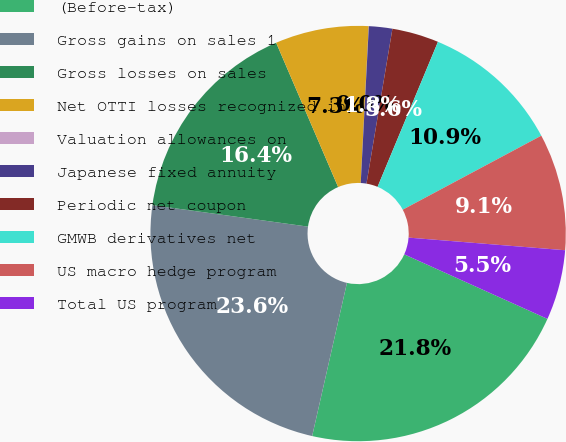Convert chart to OTSL. <chart><loc_0><loc_0><loc_500><loc_500><pie_chart><fcel>(Before-tax)<fcel>Gross gains on sales 1<fcel>Gross losses on sales<fcel>Net OTTI losses recognized in<fcel>Valuation allowances on<fcel>Japanese fixed annuity<fcel>Periodic net coupon<fcel>GMWB derivatives net<fcel>US macro hedge program<fcel>Total US program<nl><fcel>21.81%<fcel>23.63%<fcel>16.36%<fcel>7.27%<fcel>0.01%<fcel>1.82%<fcel>3.64%<fcel>10.91%<fcel>9.09%<fcel>5.46%<nl></chart> 